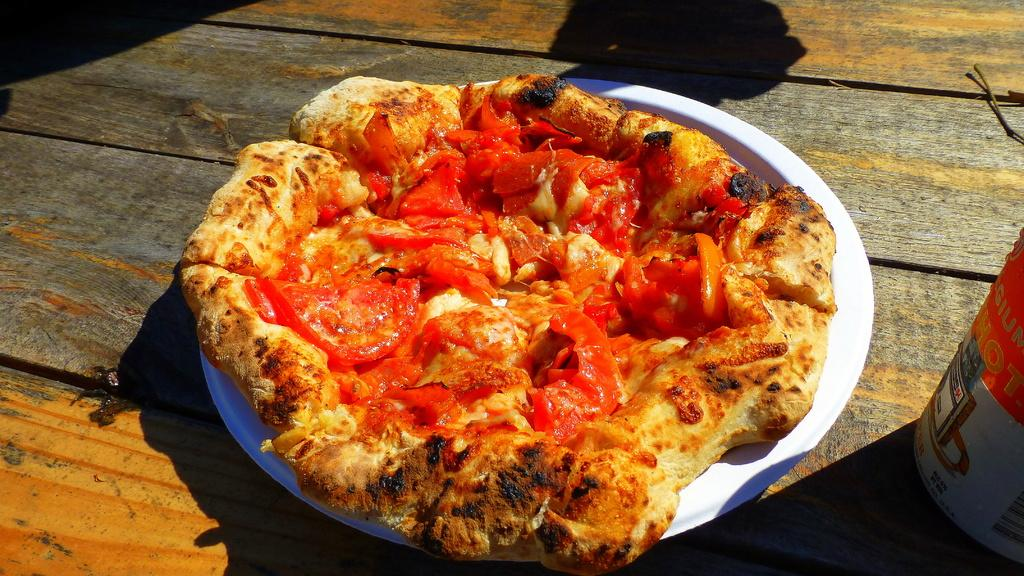What type of food can be seen in the image? The food in the image has brown and red colors. What is the color of the plate that holds the food? The plate is white. Where is the plate with food located? The plate is on a table. Is the baby sitting on the stove in the image? There is no baby or stove present in the image. 